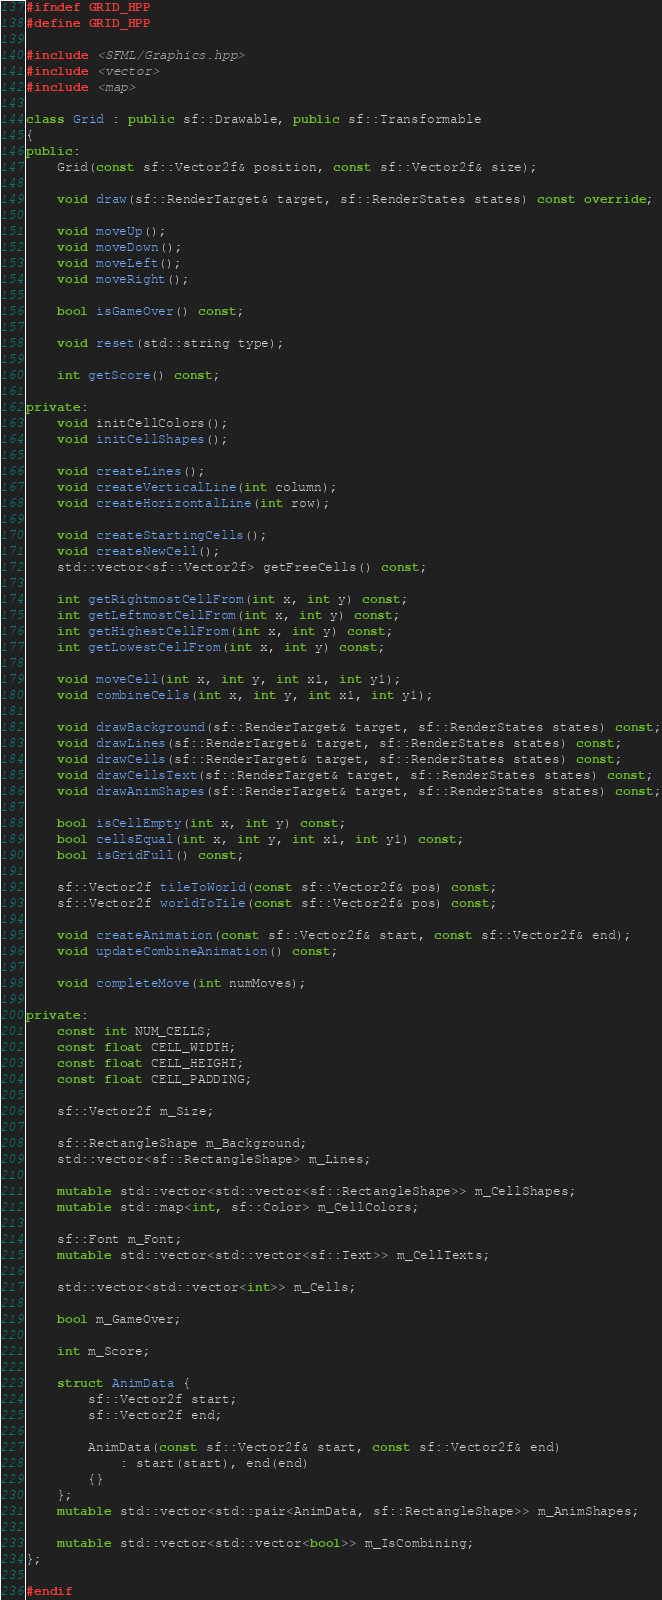Convert code to text. <code><loc_0><loc_0><loc_500><loc_500><_C++_>#ifndef GRID_HPP
#define GRID_HPP

#include <SFML/Graphics.hpp>
#include <vector>
#include <map>

class Grid : public sf::Drawable, public sf::Transformable
{
public:
	Grid(const sf::Vector2f& position, const sf::Vector2f& size);

	void draw(sf::RenderTarget& target, sf::RenderStates states) const override;

	void moveUp();
	void moveDown();
	void moveLeft();
	void moveRight();

	bool isGameOver() const;

	void reset(std::string type);

	int getScore() const;

private:
	void initCellColors();
	void initCellShapes();

	void createLines();
	void createVerticalLine(int column);
	void createHorizontalLine(int row);

	void createStartingCells();
	void createNewCell();
	std::vector<sf::Vector2f> getFreeCells() const;

	int getRightmostCellFrom(int x, int y) const;
	int getLeftmostCellFrom(int x, int y) const;
	int getHighestCellFrom(int x, int y) const;
	int getLowestCellFrom(int x, int y) const;

	void moveCell(int x, int y, int x1, int y1);
	void combineCells(int x, int y, int x1, int y1);

	void drawBackground(sf::RenderTarget& target, sf::RenderStates states) const;
	void drawLines(sf::RenderTarget& target, sf::RenderStates states) const;
	void drawCells(sf::RenderTarget& target, sf::RenderStates states) const;
	void drawCellsText(sf::RenderTarget& target, sf::RenderStates states) const;
	void drawAnimShapes(sf::RenderTarget& target, sf::RenderStates states) const;

	bool isCellEmpty(int x, int y) const;
	bool cellsEqual(int x, int y, int x1, int y1) const;
	bool isGridFull() const;

	sf::Vector2f tileToWorld(const sf::Vector2f& pos) const;
	sf::Vector2f worldToTile(const sf::Vector2f& pos) const;

	void createAnimation(const sf::Vector2f& start, const sf::Vector2f& end);
	void updateCombineAnimation() const;

	void completeMove(int numMoves);

private:
	const int NUM_CELLS;
	const float CELL_WIDTH;
	const float CELL_HEIGHT;
	const float CELL_PADDING;

	sf::Vector2f m_Size;

	sf::RectangleShape m_Background;
	std::vector<sf::RectangleShape> m_Lines;

	mutable std::vector<std::vector<sf::RectangleShape>> m_CellShapes;
	mutable std::map<int, sf::Color> m_CellColors;

	sf::Font m_Font;
	mutable std::vector<std::vector<sf::Text>> m_CellTexts;

	std::vector<std::vector<int>> m_Cells;

	bool m_GameOver;

	int m_Score;

	struct AnimData {
		sf::Vector2f start;
		sf::Vector2f end;

		AnimData(const sf::Vector2f& start, const sf::Vector2f& end)
			: start(start), end(end)
		{}
	};
	mutable std::vector<std::pair<AnimData, sf::RectangleShape>> m_AnimShapes;

	mutable std::vector<std::vector<bool>> m_IsCombining;
};

#endif
</code> 